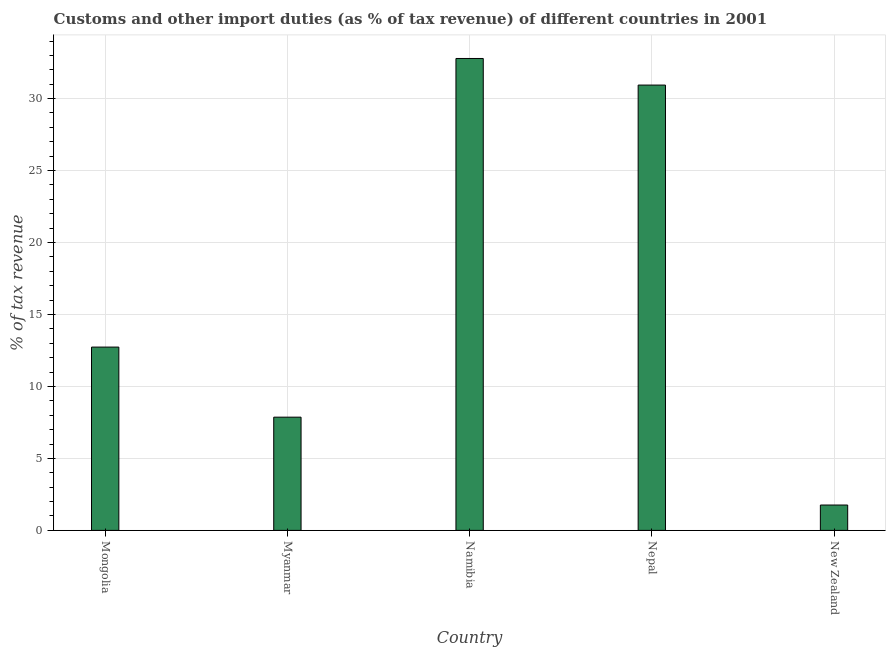Does the graph contain grids?
Provide a short and direct response. Yes. What is the title of the graph?
Offer a terse response. Customs and other import duties (as % of tax revenue) of different countries in 2001. What is the label or title of the X-axis?
Provide a short and direct response. Country. What is the label or title of the Y-axis?
Provide a succinct answer. % of tax revenue. What is the customs and other import duties in Myanmar?
Keep it short and to the point. 7.87. Across all countries, what is the maximum customs and other import duties?
Offer a terse response. 32.79. Across all countries, what is the minimum customs and other import duties?
Ensure brevity in your answer.  1.76. In which country was the customs and other import duties maximum?
Ensure brevity in your answer.  Namibia. In which country was the customs and other import duties minimum?
Your response must be concise. New Zealand. What is the sum of the customs and other import duties?
Keep it short and to the point. 86.09. What is the difference between the customs and other import duties in Namibia and Nepal?
Keep it short and to the point. 1.85. What is the average customs and other import duties per country?
Provide a succinct answer. 17.22. What is the median customs and other import duties?
Offer a very short reply. 12.74. What is the ratio of the customs and other import duties in Mongolia to that in Myanmar?
Your response must be concise. 1.62. Is the customs and other import duties in Namibia less than that in New Zealand?
Offer a very short reply. No. Is the difference between the customs and other import duties in Mongolia and Nepal greater than the difference between any two countries?
Make the answer very short. No. What is the difference between the highest and the second highest customs and other import duties?
Ensure brevity in your answer.  1.85. What is the difference between the highest and the lowest customs and other import duties?
Give a very brief answer. 31.03. In how many countries, is the customs and other import duties greater than the average customs and other import duties taken over all countries?
Your answer should be very brief. 2. Are all the bars in the graph horizontal?
Give a very brief answer. No. How many countries are there in the graph?
Ensure brevity in your answer.  5. Are the values on the major ticks of Y-axis written in scientific E-notation?
Your response must be concise. No. What is the % of tax revenue in Mongolia?
Provide a short and direct response. 12.74. What is the % of tax revenue in Myanmar?
Provide a short and direct response. 7.87. What is the % of tax revenue of Namibia?
Your answer should be very brief. 32.79. What is the % of tax revenue in Nepal?
Keep it short and to the point. 30.94. What is the % of tax revenue of New Zealand?
Provide a short and direct response. 1.76. What is the difference between the % of tax revenue in Mongolia and Myanmar?
Provide a short and direct response. 4.87. What is the difference between the % of tax revenue in Mongolia and Namibia?
Make the answer very short. -20.05. What is the difference between the % of tax revenue in Mongolia and Nepal?
Provide a short and direct response. -18.2. What is the difference between the % of tax revenue in Mongolia and New Zealand?
Your answer should be compact. 10.97. What is the difference between the % of tax revenue in Myanmar and Namibia?
Ensure brevity in your answer.  -24.92. What is the difference between the % of tax revenue in Myanmar and Nepal?
Your response must be concise. -23.07. What is the difference between the % of tax revenue in Myanmar and New Zealand?
Make the answer very short. 6.1. What is the difference between the % of tax revenue in Namibia and Nepal?
Keep it short and to the point. 1.85. What is the difference between the % of tax revenue in Namibia and New Zealand?
Make the answer very short. 31.03. What is the difference between the % of tax revenue in Nepal and New Zealand?
Offer a terse response. 29.18. What is the ratio of the % of tax revenue in Mongolia to that in Myanmar?
Give a very brief answer. 1.62. What is the ratio of the % of tax revenue in Mongolia to that in Namibia?
Offer a very short reply. 0.39. What is the ratio of the % of tax revenue in Mongolia to that in Nepal?
Offer a terse response. 0.41. What is the ratio of the % of tax revenue in Mongolia to that in New Zealand?
Your answer should be very brief. 7.23. What is the ratio of the % of tax revenue in Myanmar to that in Namibia?
Ensure brevity in your answer.  0.24. What is the ratio of the % of tax revenue in Myanmar to that in Nepal?
Make the answer very short. 0.25. What is the ratio of the % of tax revenue in Myanmar to that in New Zealand?
Offer a very short reply. 4.46. What is the ratio of the % of tax revenue in Namibia to that in Nepal?
Make the answer very short. 1.06. What is the ratio of the % of tax revenue in Namibia to that in New Zealand?
Your answer should be compact. 18.6. What is the ratio of the % of tax revenue in Nepal to that in New Zealand?
Your answer should be very brief. 17.56. 